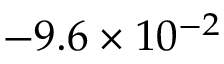<formula> <loc_0><loc_0><loc_500><loc_500>- 9 . 6 \times 1 0 ^ { - 2 }</formula> 